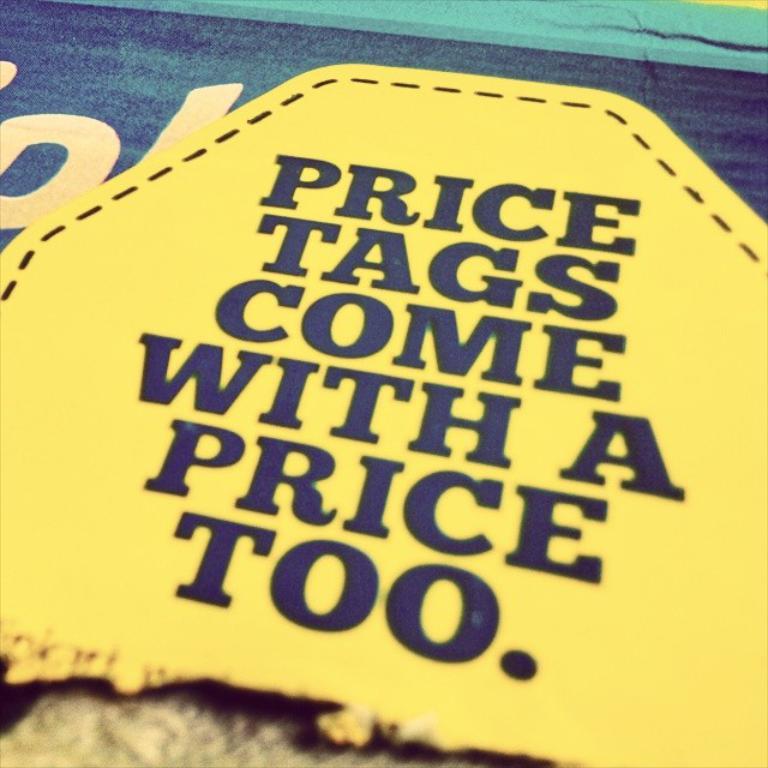What comes with a price?
Your response must be concise. Price tags. What is the second word?
Offer a terse response. Tags. 